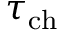<formula> <loc_0><loc_0><loc_500><loc_500>\tau _ { c h }</formula> 